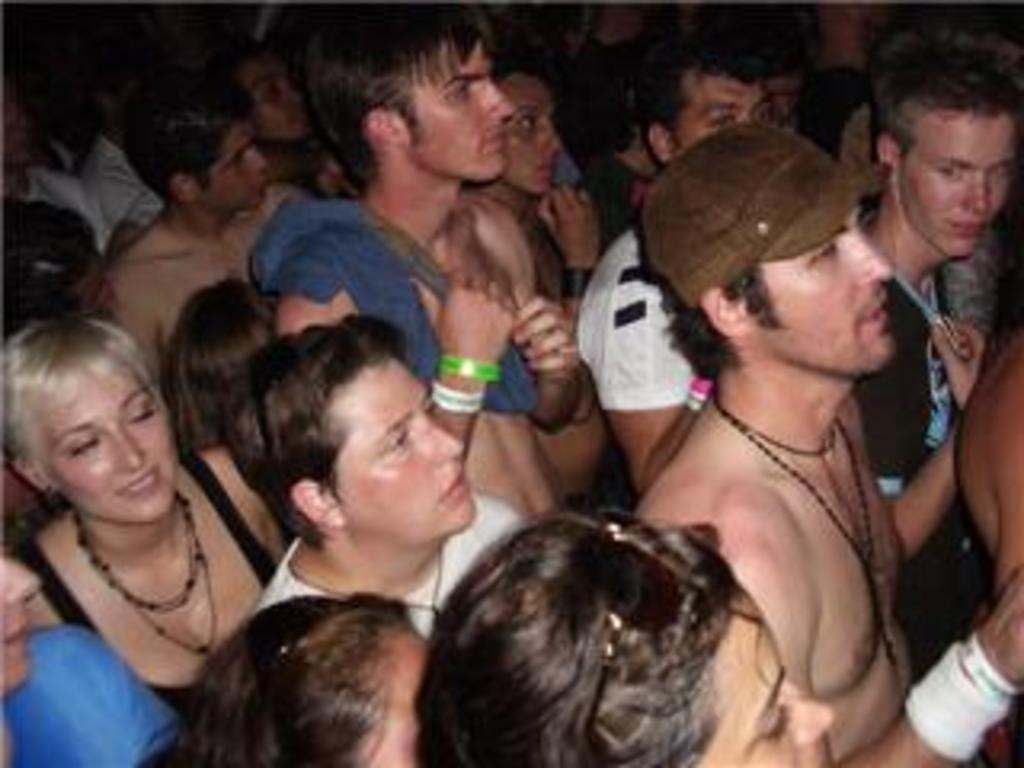How many people are in the image? The number of people in the image cannot be determined from the provided fact. What type of drink is being held by the person with a fang in the image? There is no person with a fang holding a drink in the image, as the provided fact does not mention any such details. 